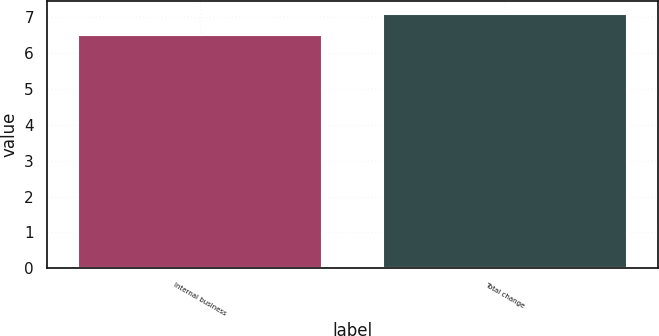Convert chart to OTSL. <chart><loc_0><loc_0><loc_500><loc_500><bar_chart><fcel>Internal business<fcel>Total change<nl><fcel>6.5<fcel>7.1<nl></chart> 